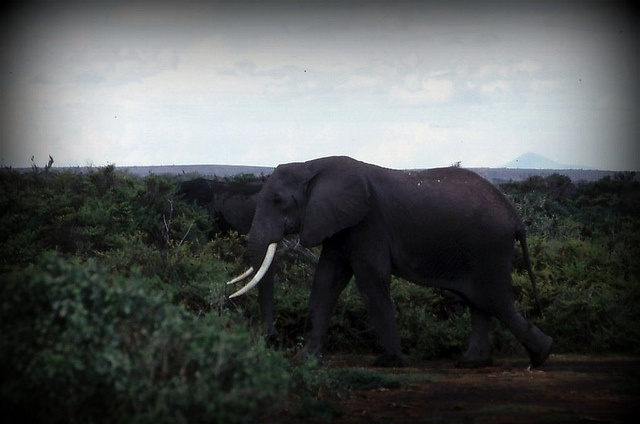Describe the objects in this image and their specific colors. I can see a elephant in black and gray tones in this image. 